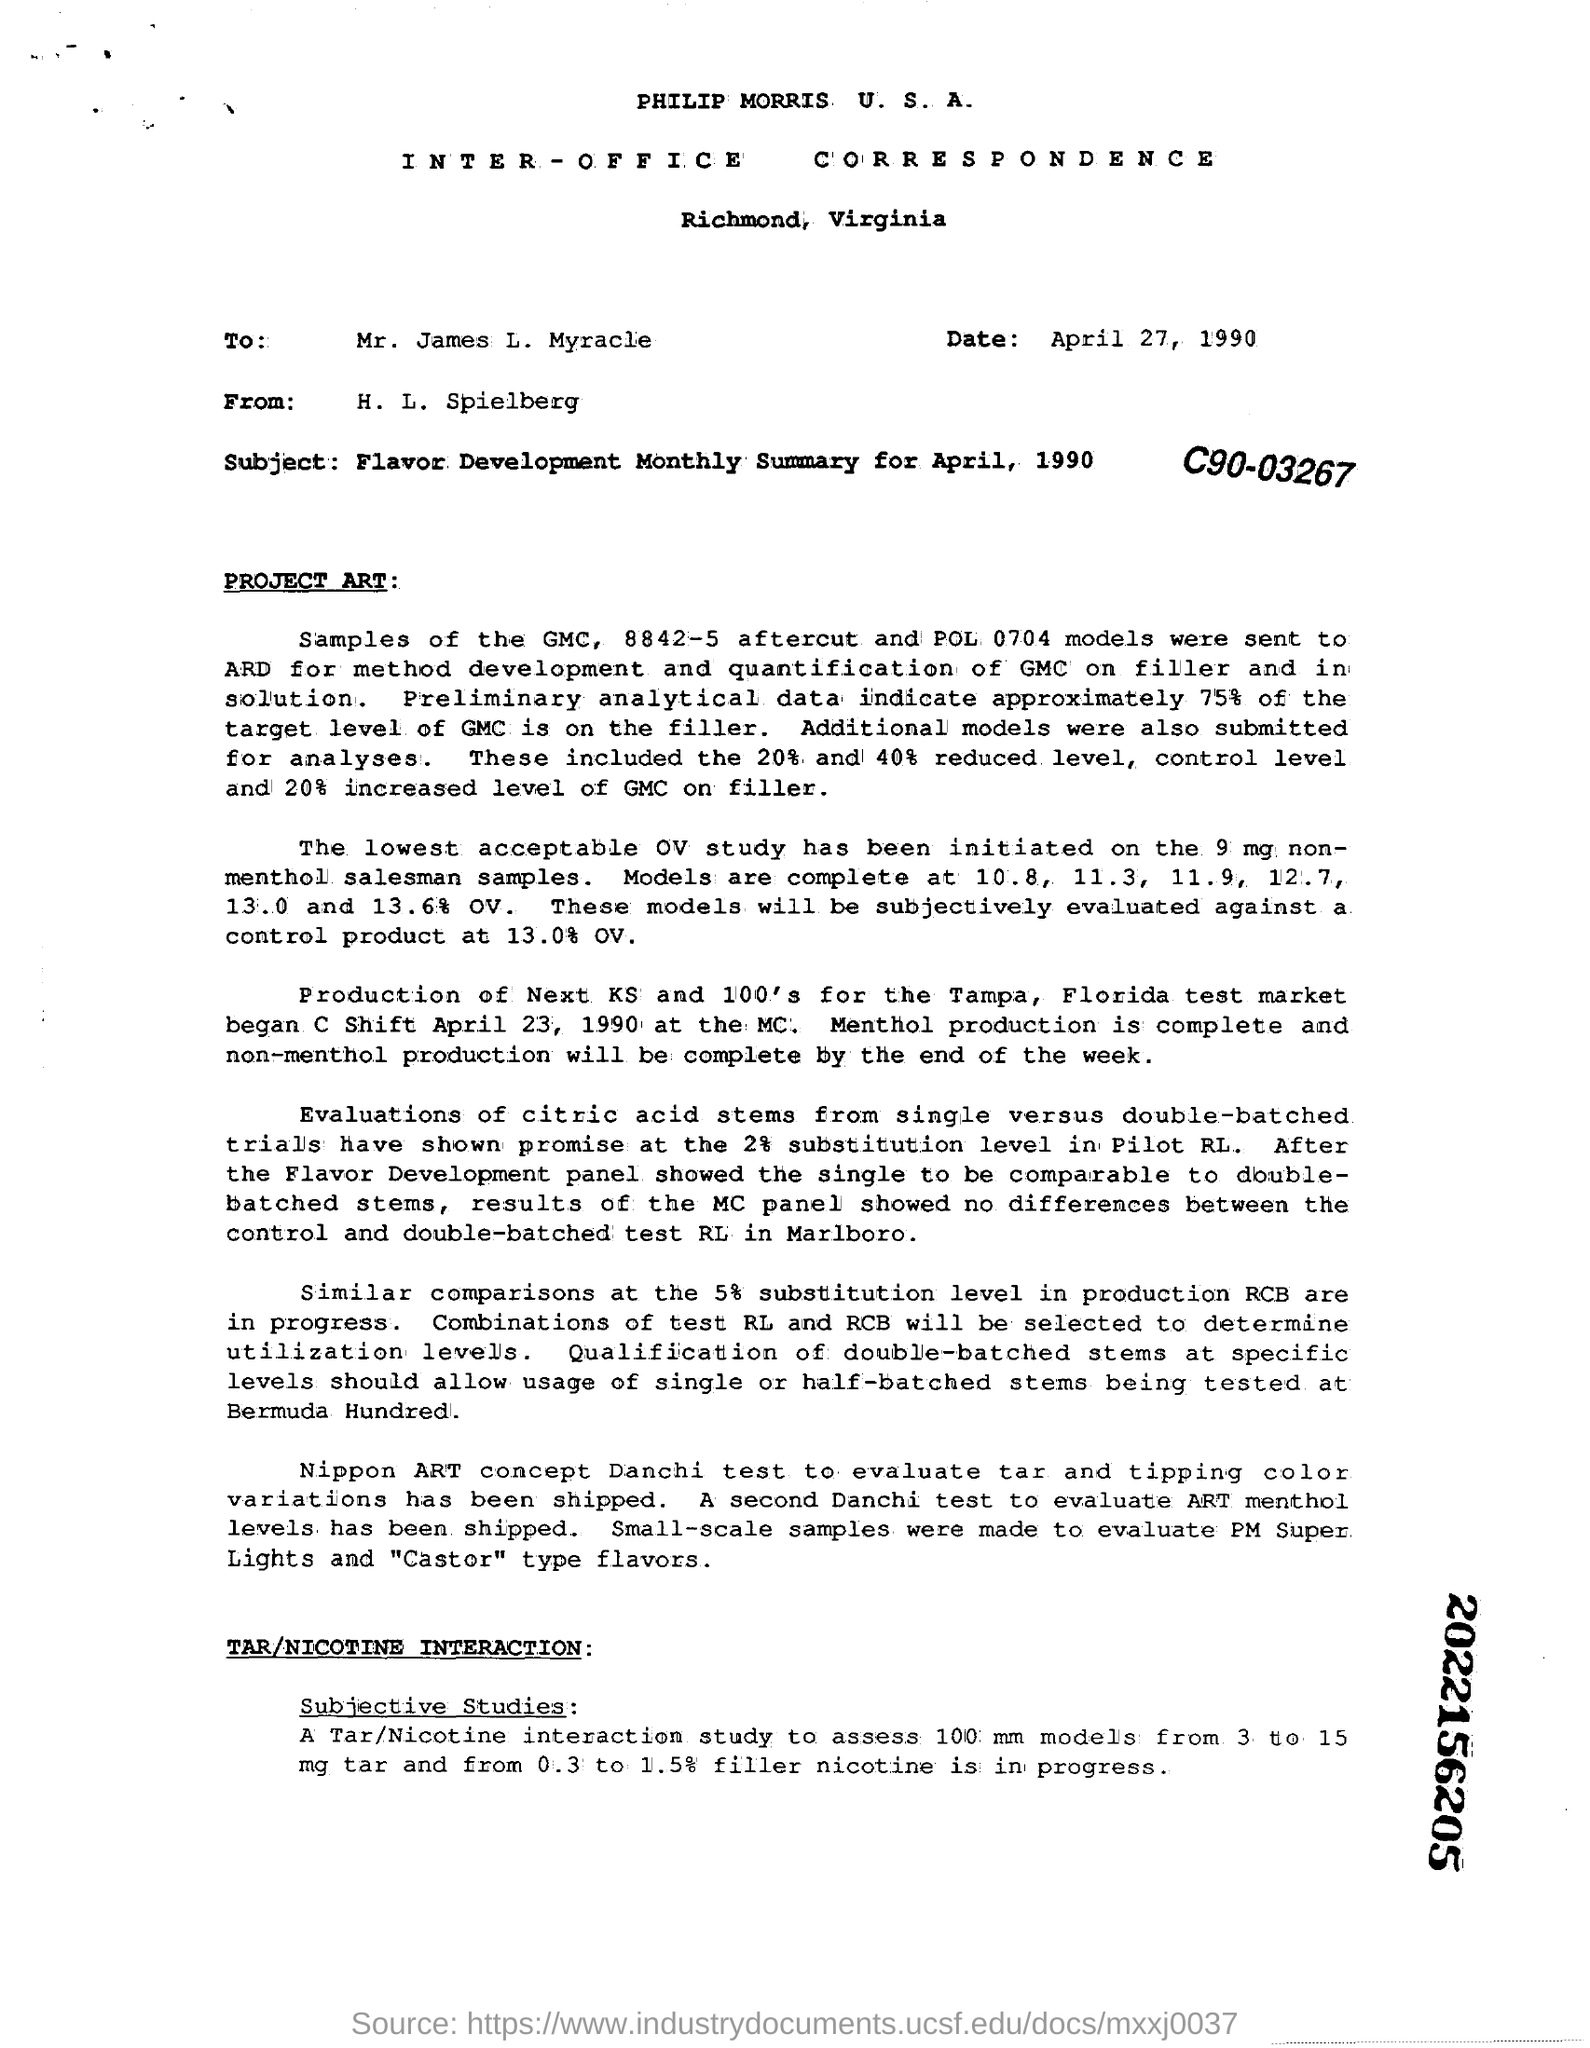What sort of communication/letter is this ?
Provide a short and direct response. INTER-OFFICE CORRESPONDENCE. What is the date mentioned in the letter?
Ensure brevity in your answer.  April 27, 1990. Which test is used to evaluate ART menthol levels that has been shipped?
Keep it short and to the point. A second Danchi Test. What is the subject of the document/letter?
Give a very brief answer. Flavor Development Monthly Summary for April, 1990. 